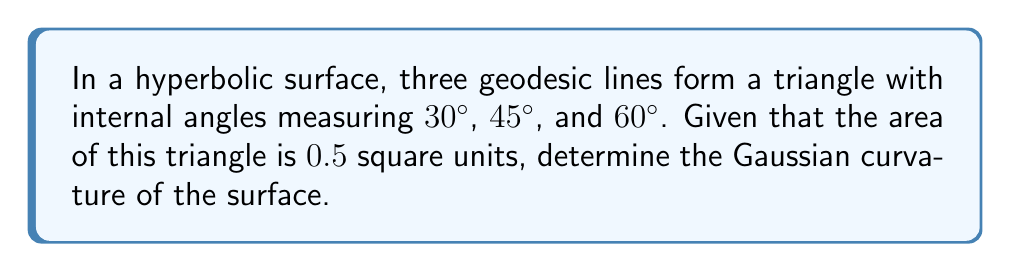Show me your answer to this math problem. Let's approach this step-by-step:

1) In hyperbolic geometry, the Gauss-Bonnet theorem relates the area of a triangle to its angles and the curvature of the surface. The formula is:

   $$A = (\pi - (\alpha + \beta + \gamma)) / (-K)$$

   Where $A$ is the area, $\alpha$, $\beta$, and $\gamma$ are the internal angles, and $K$ is the Gaussian curvature.

2) Convert the given angles to radians:
   $30° = \pi/6$
   $45° = \pi/4$
   $60° = \pi/3$

3) Sum the angles:
   $$\alpha + \beta + \gamma = \pi/6 + \pi/4 + \pi/3 = 3\pi/4$$

4) Substitute the known values into the Gauss-Bonnet formula:

   $$0.5 = (\pi - 3\pi/4) / (-K)$$

5) Simplify:
   $$0.5 = \pi/4 / (-K)$$

6) Solve for $K$:
   $$K = -(\pi/4) / 0.5 = -\pi/2$$

7) The negative sign indicates that this is indeed a hyperbolic surface (negative curvature).
Answer: $-\pi/2$ 